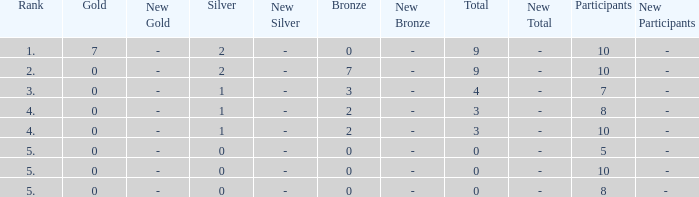What is listed as the highest Rank that has a Gold that's larger than 0, and Participants that's smaller than 10? None. 